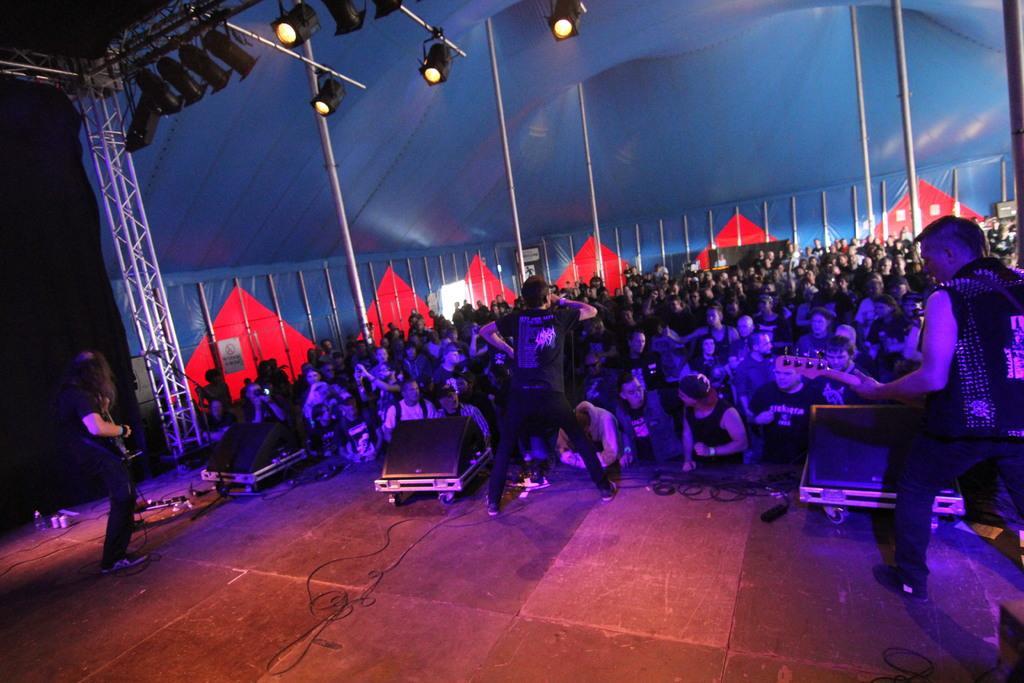In one or two sentences, can you explain what this image depicts? In this image I can see number of people, poles, lights, speakers, boards and here I can see these two are holding guitars. 